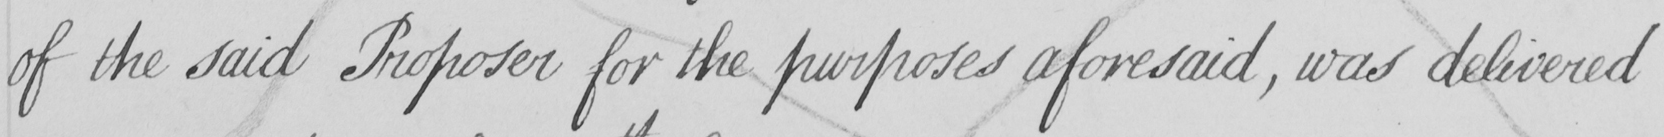Please provide the text content of this handwritten line. of the said Proposer for the purposes aforesaid , was delivered 